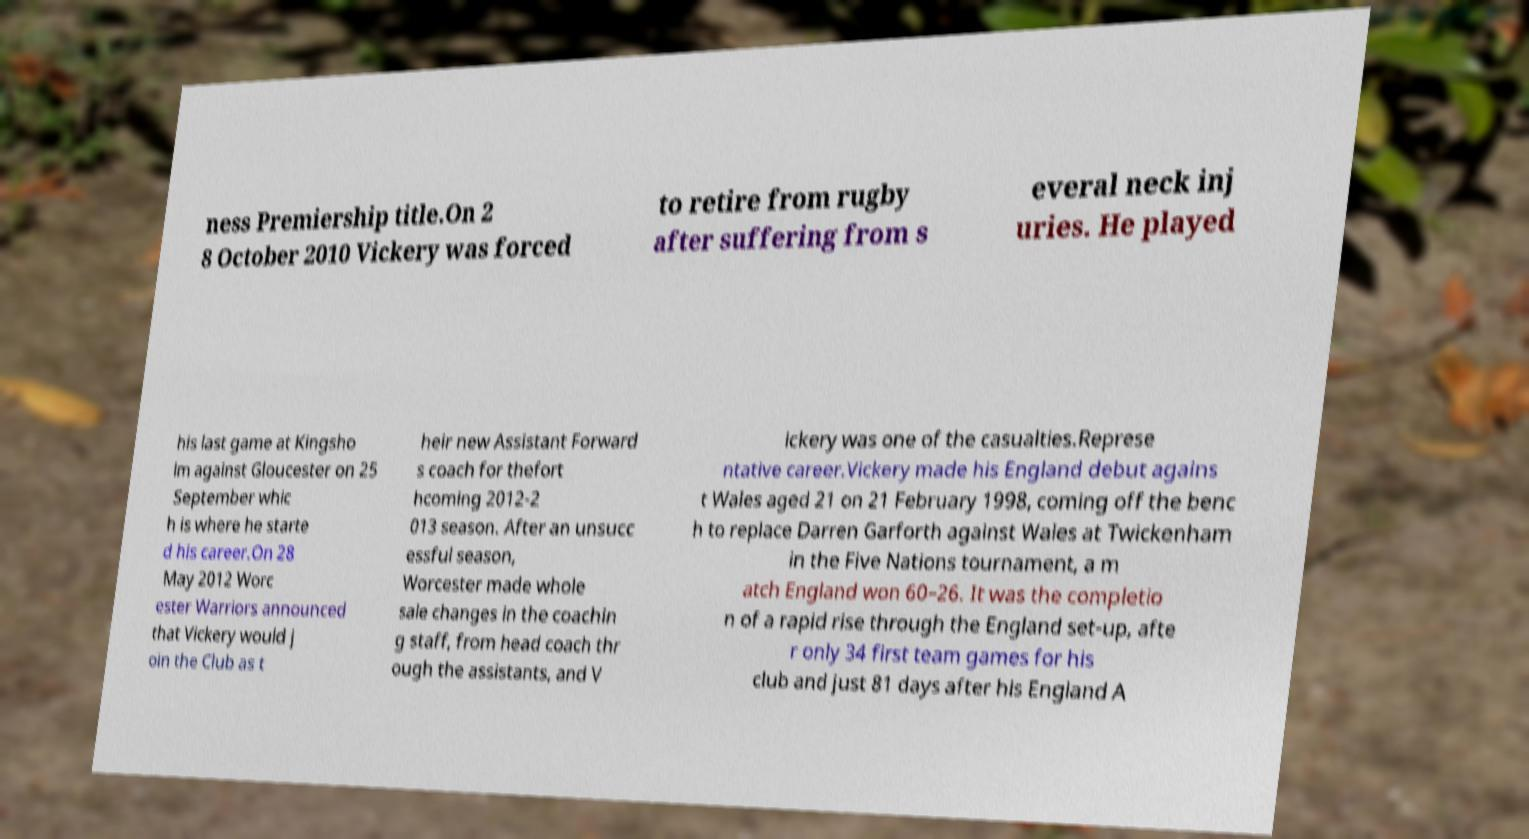For documentation purposes, I need the text within this image transcribed. Could you provide that? ness Premiership title.On 2 8 October 2010 Vickery was forced to retire from rugby after suffering from s everal neck inj uries. He played his last game at Kingsho lm against Gloucester on 25 September whic h is where he starte d his career.On 28 May 2012 Worc ester Warriors announced that Vickery would j oin the Club as t heir new Assistant Forward s coach for thefort hcoming 2012-2 013 season. After an unsucc essful season, Worcester made whole sale changes in the coachin g staff, from head coach thr ough the assistants, and V ickery was one of the casualties.Represe ntative career.Vickery made his England debut agains t Wales aged 21 on 21 February 1998, coming off the benc h to replace Darren Garforth against Wales at Twickenham in the Five Nations tournament, a m atch England won 60–26. It was the completio n of a rapid rise through the England set-up, afte r only 34 first team games for his club and just 81 days after his England A 